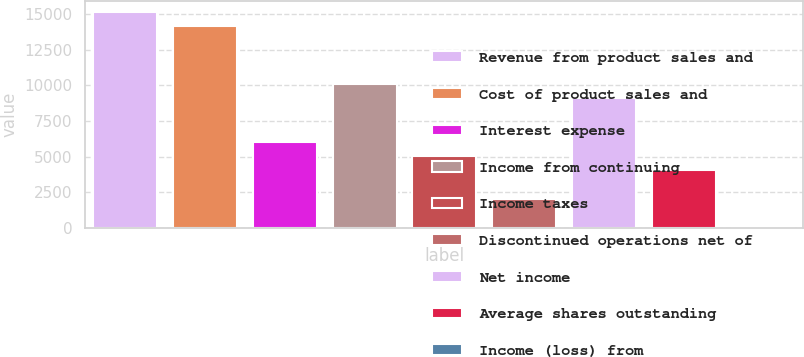Convert chart to OTSL. <chart><loc_0><loc_0><loc_500><loc_500><bar_chart><fcel>Revenue from product sales and<fcel>Cost of product sales and<fcel>Interest expense<fcel>Income from continuing<fcel>Income taxes<fcel>Discontinued operations net of<fcel>Net income<fcel>Average shares outstanding<fcel>Income (loss) from<nl><fcel>15175.5<fcel>14163.8<fcel>6070.23<fcel>10117<fcel>5058.53<fcel>2023.43<fcel>9105.33<fcel>4046.83<fcel>0.03<nl></chart> 